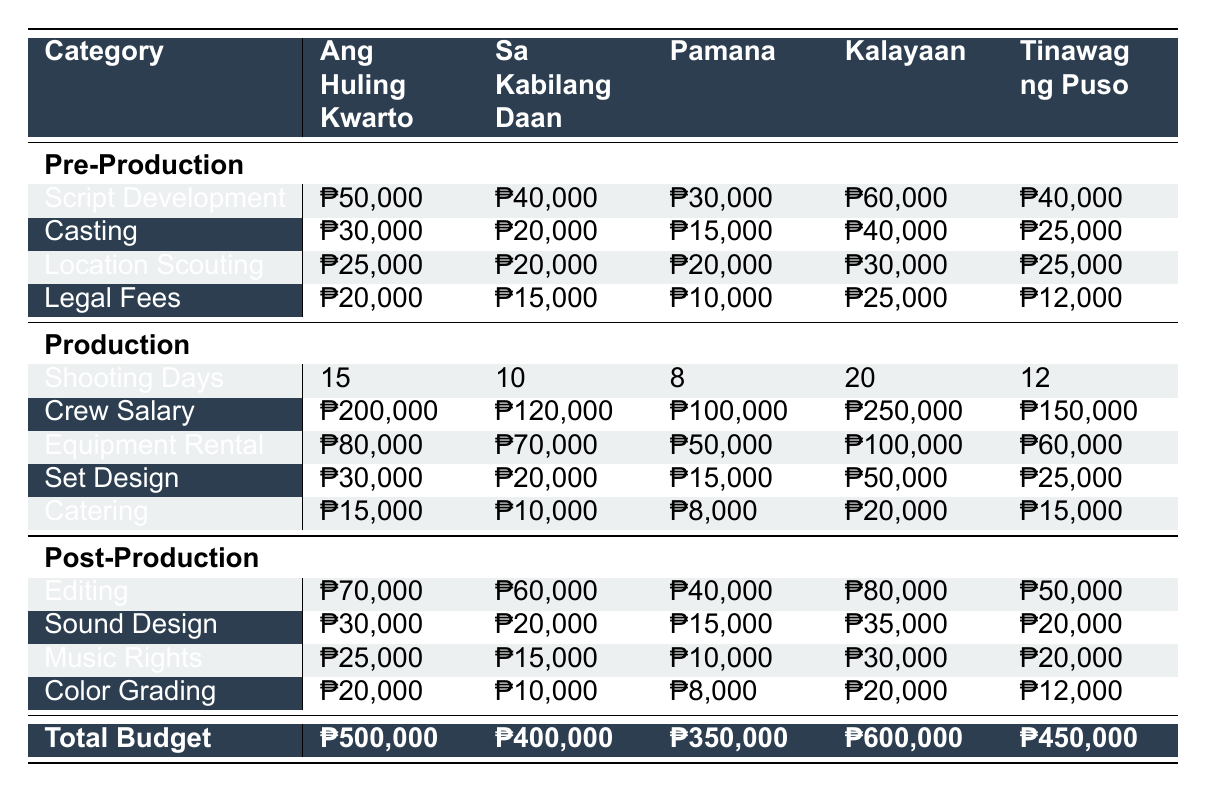What is the budget of "Kalayaan"? The budget column indicates that the budget for "Kalayaan" is ₱600,000.
Answer: ₱600,000 How many shooting days did "Pamana" have? The production section for "Pamana" shows the shooting days as 8.
Answer: 8 Which film has the highest crew salary? Looking at the crew salary values, "Kalayaan" has the highest crew salary of ₱250,000.
Answer: ₱250,000 What is the total budget for all films combined? The budgets for all films are ₱500,000 (Ang Huling Kwarto) + ₱400,000 (Sa Kabilang Daan) + ₱350,000 (Pamana) + ₱600,000 (Kalayaan) + ₱450,000 (Tinawag ng Puso), which sums to ₱2,300,000.
Answer: ₱2,300,000 Which film had the lowest budget? By reviewing the budget column, "Pamana" has the lowest budget of ₱350,000 among the films listed.
Answer: ₱350,000 How much was spent on sound design in "Tinawag ng Puso"? In the post-production section for "Tinawag ng Puso," the sound design cost is listed as ₱20,000.
Answer: ₱20,000 Which pre-production category has the highest expenditure for "Ang Huling Kwarto"? Reviewing the pre-production costs for "Ang Huling Kwarto," the script development has the highest expenditure at ₱50,000.
Answer: ₱50,000 What is the average budget allocated for post-production across all films? The post-production budgets total to ₱70,000 (Ang Huling Kwarto) + ₱60,000 (Sa Kabilang Daan) + ₱40,000 (Pamana) + ₱80,000 (Kalayaan) + ₱50,000 (Tinawag ng Puso) = ₱300,000, and dividing by the 5 films gives an average of ₱60,000.
Answer: ₱60,000 Did "Sa Kabilang Daan" spend more on pre-production than "Pamana"? "Sa Kabilang Daan" has a total pre-production cost of ₱105,000 (₱40,000 + ₱20,000 + ₱20,000 + ₱15,000), while "Pamana" has a pre-production total of ₱75,000 (₱30,000 + ₱15,000 + ₱20,000 + ₱10,000), so yes, "Sa Kabilang Daan" spent more.
Answer: Yes What is the difference in budget between "Kalayaan" and "Tinawag ng Puso"? The budgets are ₱600,000 for "Kalayaan" and ₱450,000 for "Tinawag ng Puso". The difference is ₱600,000 - ₱450,000 = ₱150,000.
Answer: ₱150,000 